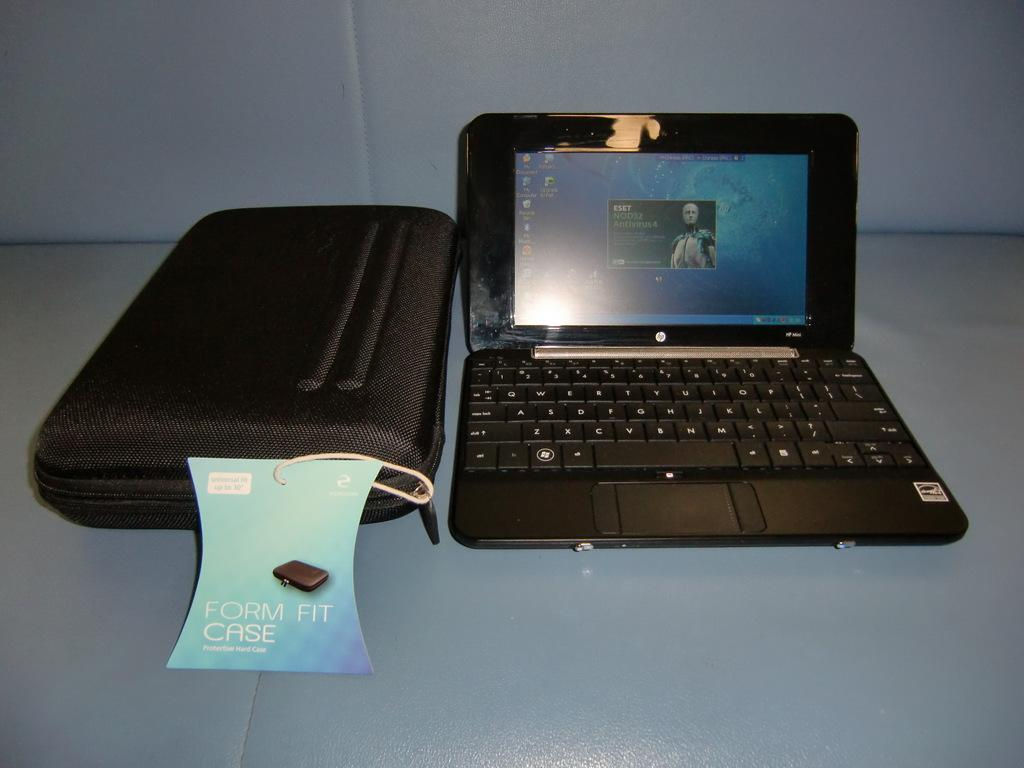<image>
Create a compact narrative representing the image presented. HP laptop monitor next to a case that says Form Fit Case. 